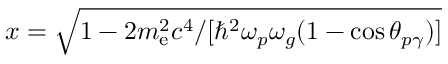Convert formula to latex. <formula><loc_0><loc_0><loc_500><loc_500>x = \sqrt { 1 - 2 m _ { e } ^ { 2 } c ^ { 4 } / [ \hbar { ^ } { 2 } \omega _ { p } \omega _ { g } ( 1 - \cos \theta _ { p \gamma } ) ] }</formula> 